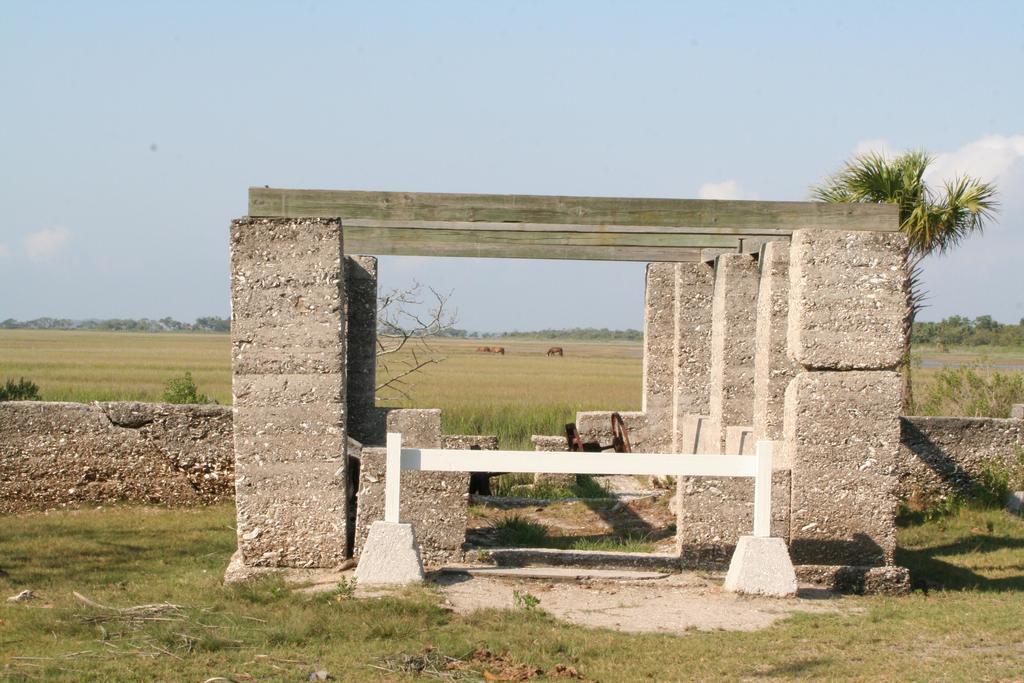Could you give a brief overview of what you see in this image? In this image I can see an open grass ground and on it I can see a white colour hurdle, a brown colour thing, number of stone pillars and the stone wall. On the top of the pillars I can see few wooden things. In the background I can see number of trees, few plants, clouds and the sky. 